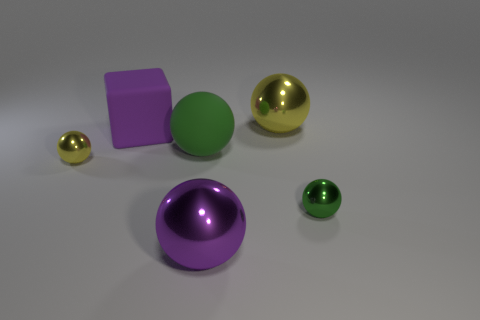There is a large shiny object that is behind the purple metallic ball; what number of big yellow shiny objects are on the left side of it?
Give a very brief answer. 0. There is a big green object that is the same shape as the purple metallic object; what material is it?
Keep it short and to the point. Rubber. What number of green objects are big things or cubes?
Your response must be concise. 1. There is a big rubber object that is in front of the large purple matte object that is right of the small yellow sphere; what is its color?
Your answer should be very brief. Green. Are there fewer large yellow metallic balls that are behind the purple shiny thing than things on the left side of the small green object?
Your answer should be compact. Yes. How many things are small metal objects that are right of the big rubber block or cubes?
Your answer should be very brief. 2. Do the yellow metal thing on the left side of the purple matte block and the green shiny ball have the same size?
Provide a succinct answer. Yes. Is the number of green metal spheres behind the large yellow sphere less than the number of big blue metal blocks?
Provide a short and direct response. No. There is a green sphere that is the same size as the purple cube; what is it made of?
Your response must be concise. Rubber. What number of big objects are green rubber objects or green objects?
Offer a terse response. 1. 